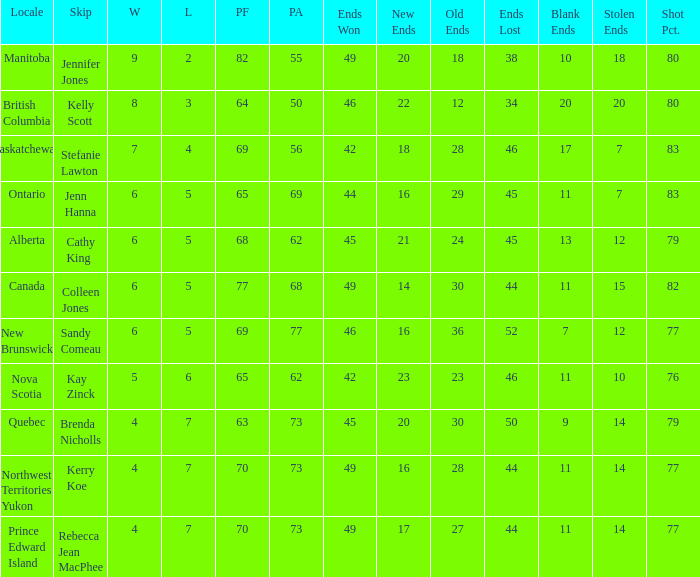What is the sum of ends won in the northwest territories yukon region? 1.0. 